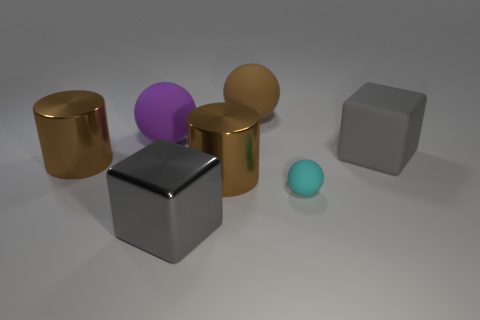Do the metal cube and the matte cube have the same color?
Provide a succinct answer. Yes. What is the size of the brown thing that is both in front of the purple sphere and to the right of the gray shiny cube?
Provide a short and direct response. Large. There is a large brown metal object on the right side of the big gray metal thing in front of the purple sphere; what shape is it?
Offer a very short reply. Cylinder. Are there any other things of the same color as the metallic cube?
Make the answer very short. Yes. What shape is the matte thing that is in front of the big gray rubber block?
Offer a very short reply. Sphere. There is a big brown object that is right of the large purple rubber sphere and in front of the large purple rubber object; what shape is it?
Offer a terse response. Cylinder. What number of red things are matte balls or cubes?
Provide a short and direct response. 0. There is a block that is on the right side of the gray metal thing; does it have the same color as the shiny block?
Provide a succinct answer. Yes. What is the size of the brown cylinder that is right of the ball that is on the left side of the brown ball?
Offer a very short reply. Large. There is a purple sphere that is the same size as the brown sphere; what material is it?
Provide a short and direct response. Rubber. 